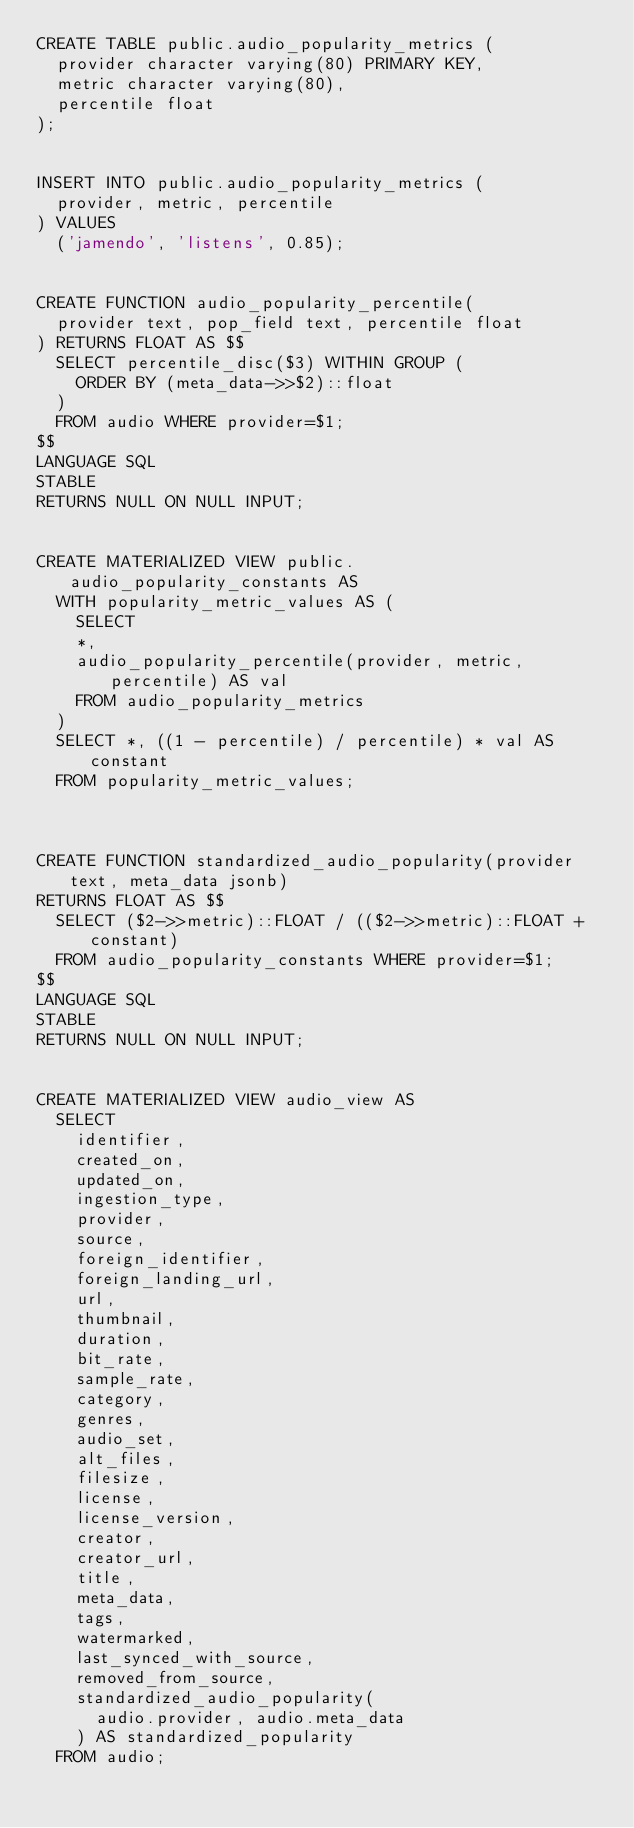Convert code to text. <code><loc_0><loc_0><loc_500><loc_500><_SQL_>CREATE TABLE public.audio_popularity_metrics (
  provider character varying(80) PRIMARY KEY,
  metric character varying(80),
  percentile float
);


INSERT INTO public.audio_popularity_metrics (
  provider, metric, percentile
) VALUES
  ('jamendo', 'listens', 0.85);


CREATE FUNCTION audio_popularity_percentile(
  provider text, pop_field text, percentile float
) RETURNS FLOAT AS $$
  SELECT percentile_disc($3) WITHIN GROUP (
    ORDER BY (meta_data->>$2)::float
  )
  FROM audio WHERE provider=$1;
$$
LANGUAGE SQL
STABLE
RETURNS NULL ON NULL INPUT;


CREATE MATERIALIZED VIEW public.audio_popularity_constants AS
  WITH popularity_metric_values AS (
    SELECT
    *,
    audio_popularity_percentile(provider, metric, percentile) AS val
    FROM audio_popularity_metrics
  )
  SELECT *, ((1 - percentile) / percentile) * val AS constant
  FROM popularity_metric_values;



CREATE FUNCTION standardized_audio_popularity(provider text, meta_data jsonb)
RETURNS FLOAT AS $$
  SELECT ($2->>metric)::FLOAT / (($2->>metric)::FLOAT + constant)
  FROM audio_popularity_constants WHERE provider=$1;
$$
LANGUAGE SQL
STABLE
RETURNS NULL ON NULL INPUT;


CREATE MATERIALIZED VIEW audio_view AS
  SELECT
    identifier,
    created_on,
    updated_on,
    ingestion_type,
    provider,
    source,
    foreign_identifier,
    foreign_landing_url,
    url,
    thumbnail,
    duration,
    bit_rate,
    sample_rate,
    category,
    genres,
    audio_set,
    alt_files,
    filesize,
    license,
    license_version,
    creator,
    creator_url,
    title,
    meta_data,
    tags,
    watermarked,
    last_synced_with_source,
    removed_from_source,
    standardized_audio_popularity(
      audio.provider, audio.meta_data
    ) AS standardized_popularity
  FROM audio;
</code> 